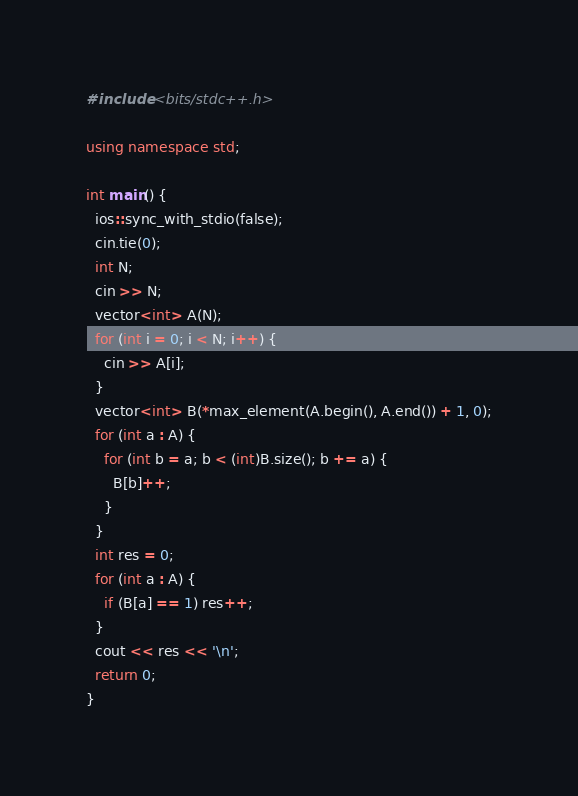Convert code to text. <code><loc_0><loc_0><loc_500><loc_500><_C++_>#include <bits/stdc++.h>

using namespace std;

int main() {
  ios::sync_with_stdio(false);
  cin.tie(0);
  int N;
  cin >> N;
  vector<int> A(N);
  for (int i = 0; i < N; i++) {
    cin >> A[i];
  }
  vector<int> B(*max_element(A.begin(), A.end()) + 1, 0);
  for (int a : A) {
    for (int b = a; b < (int)B.size(); b += a) {
      B[b]++;
    }
  }
  int res = 0;
  for (int a : A) {
    if (B[a] == 1) res++;
  }
  cout << res << '\n';
  return 0;
}
</code> 